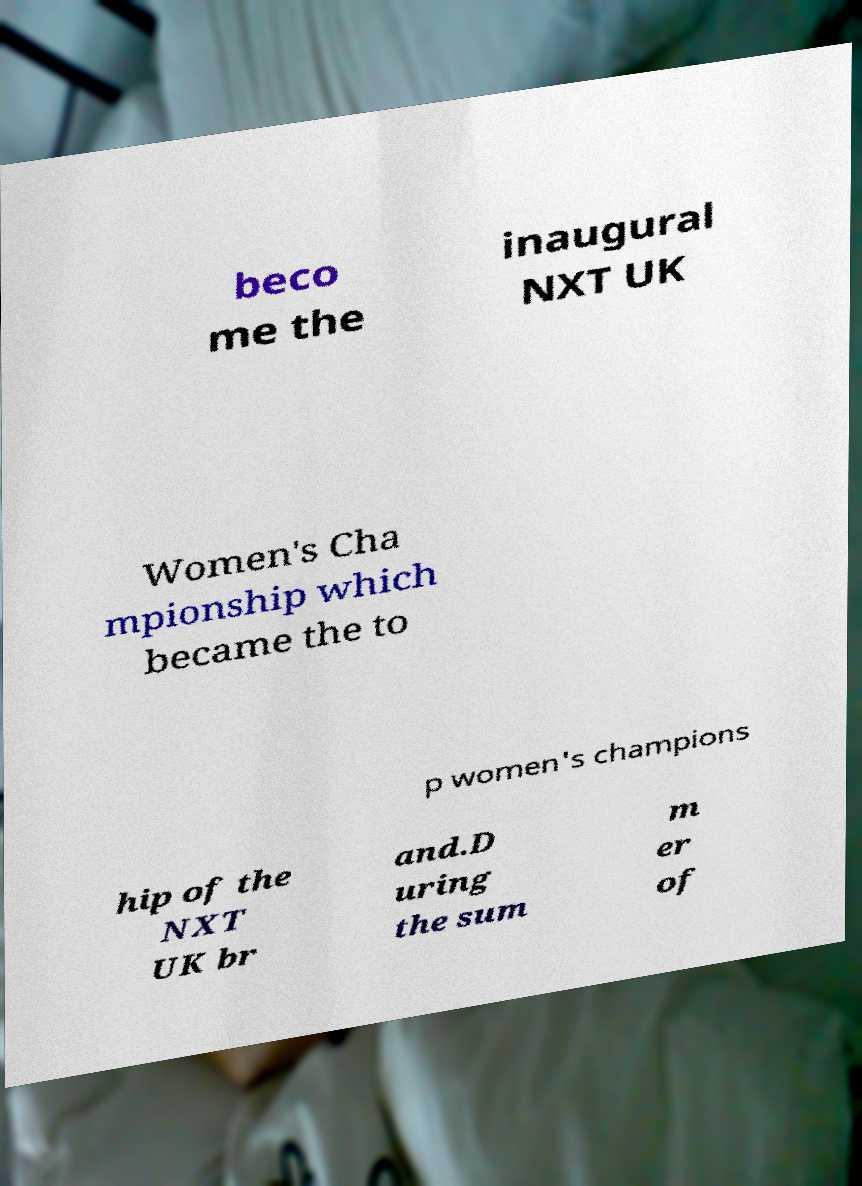For documentation purposes, I need the text within this image transcribed. Could you provide that? beco me the inaugural NXT UK Women's Cha mpionship which became the to p women's champions hip of the NXT UK br and.D uring the sum m er of 